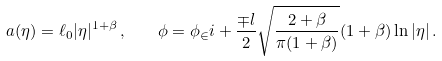Convert formula to latex. <formula><loc_0><loc_0><loc_500><loc_500>a ( \eta ) = \ell _ { 0 } | \eta | ^ { 1 + \beta } \, , \quad \phi = \phi _ { \in } i + \frac { \mp l } { 2 } \sqrt { \frac { 2 + \beta } { \pi ( 1 + \beta ) } } ( 1 + \beta ) \ln | \eta | \, .</formula> 